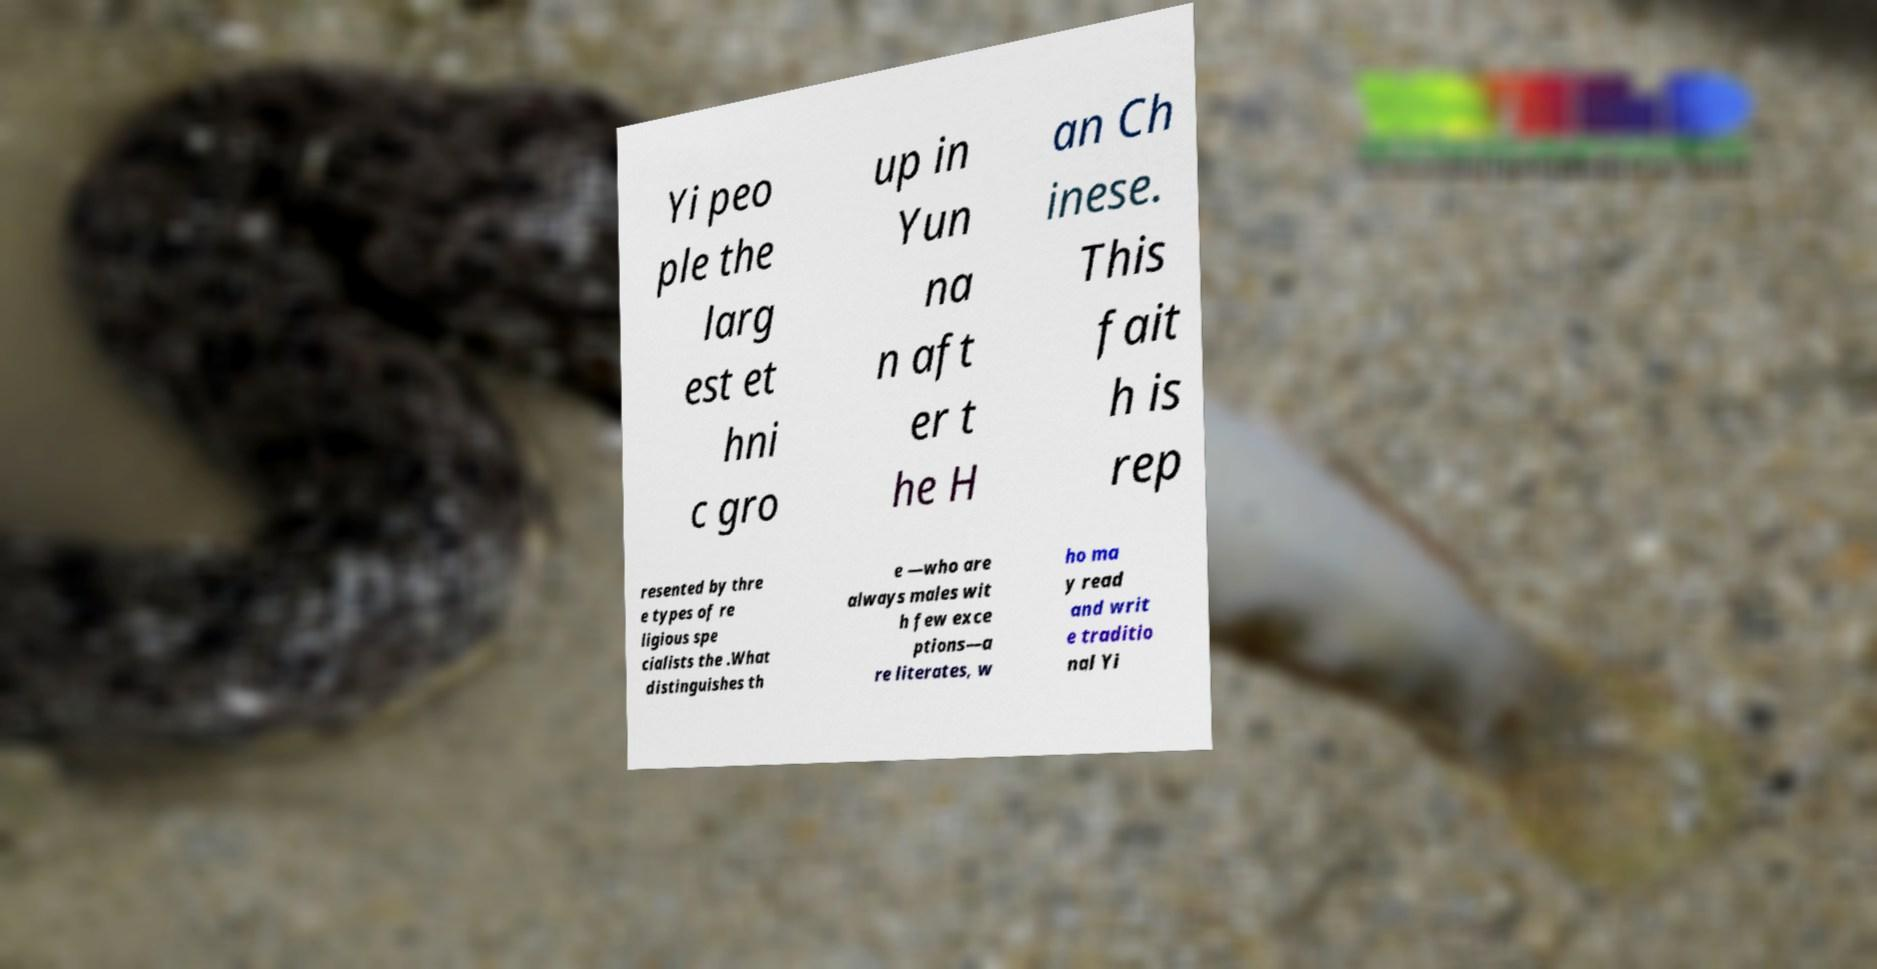There's text embedded in this image that I need extracted. Can you transcribe it verbatim? Yi peo ple the larg est et hni c gro up in Yun na n aft er t he H an Ch inese. This fait h is rep resented by thre e types of re ligious spe cialists the .What distinguishes th e —who are always males wit h few exce ptions—a re literates, w ho ma y read and writ e traditio nal Yi 